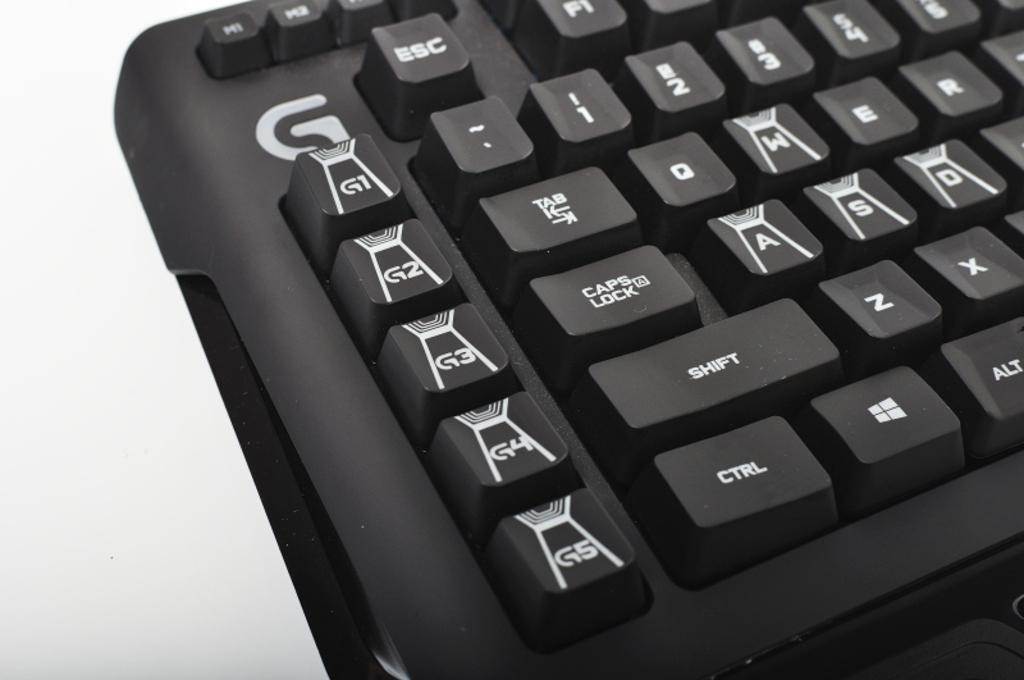How many g keys are there?
Your answer should be very brief. 5. 